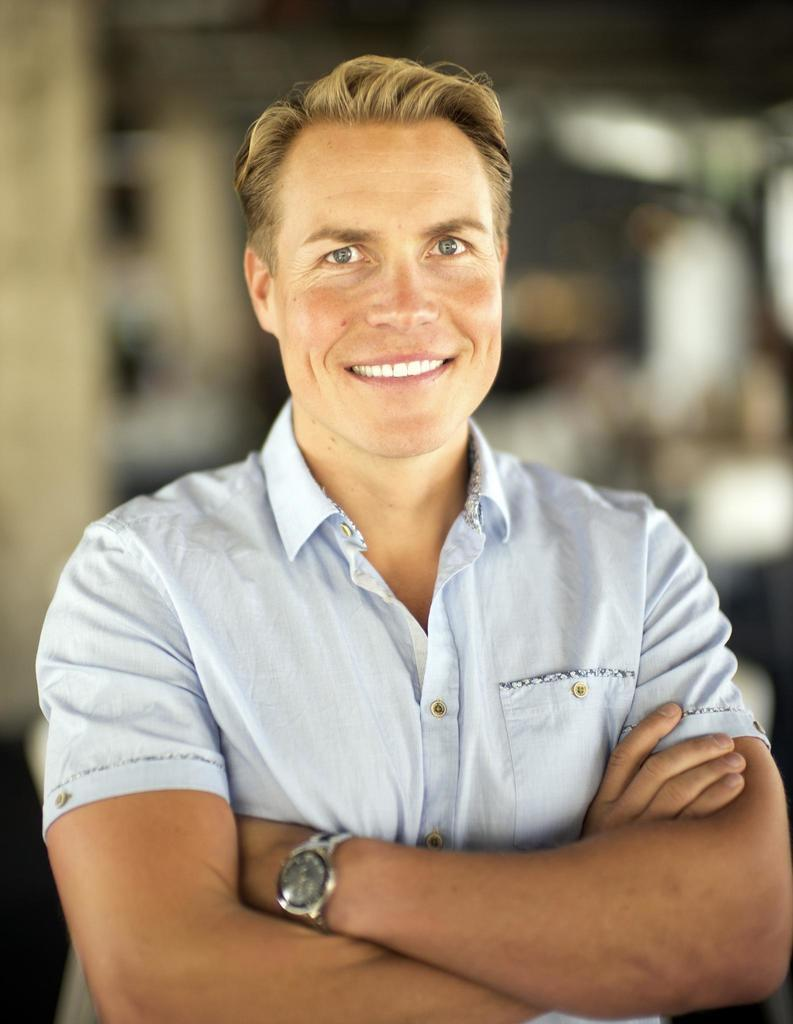What is the main subject of the picture? The main subject of the picture is a man. What is the man doing in the picture? The man is standing in the picture. What is the man's facial expression in the picture? The man is smiling in the picture. What color is the shirt the man is wearing? The man is wearing a light blue shirt. What type of wheel can be seen in the picture? There is no wheel present in the picture; it features a man standing and smiling. What kind of house is visible in the background of the picture? There is no house visible in the picture; it only shows a man standing and smiling. 